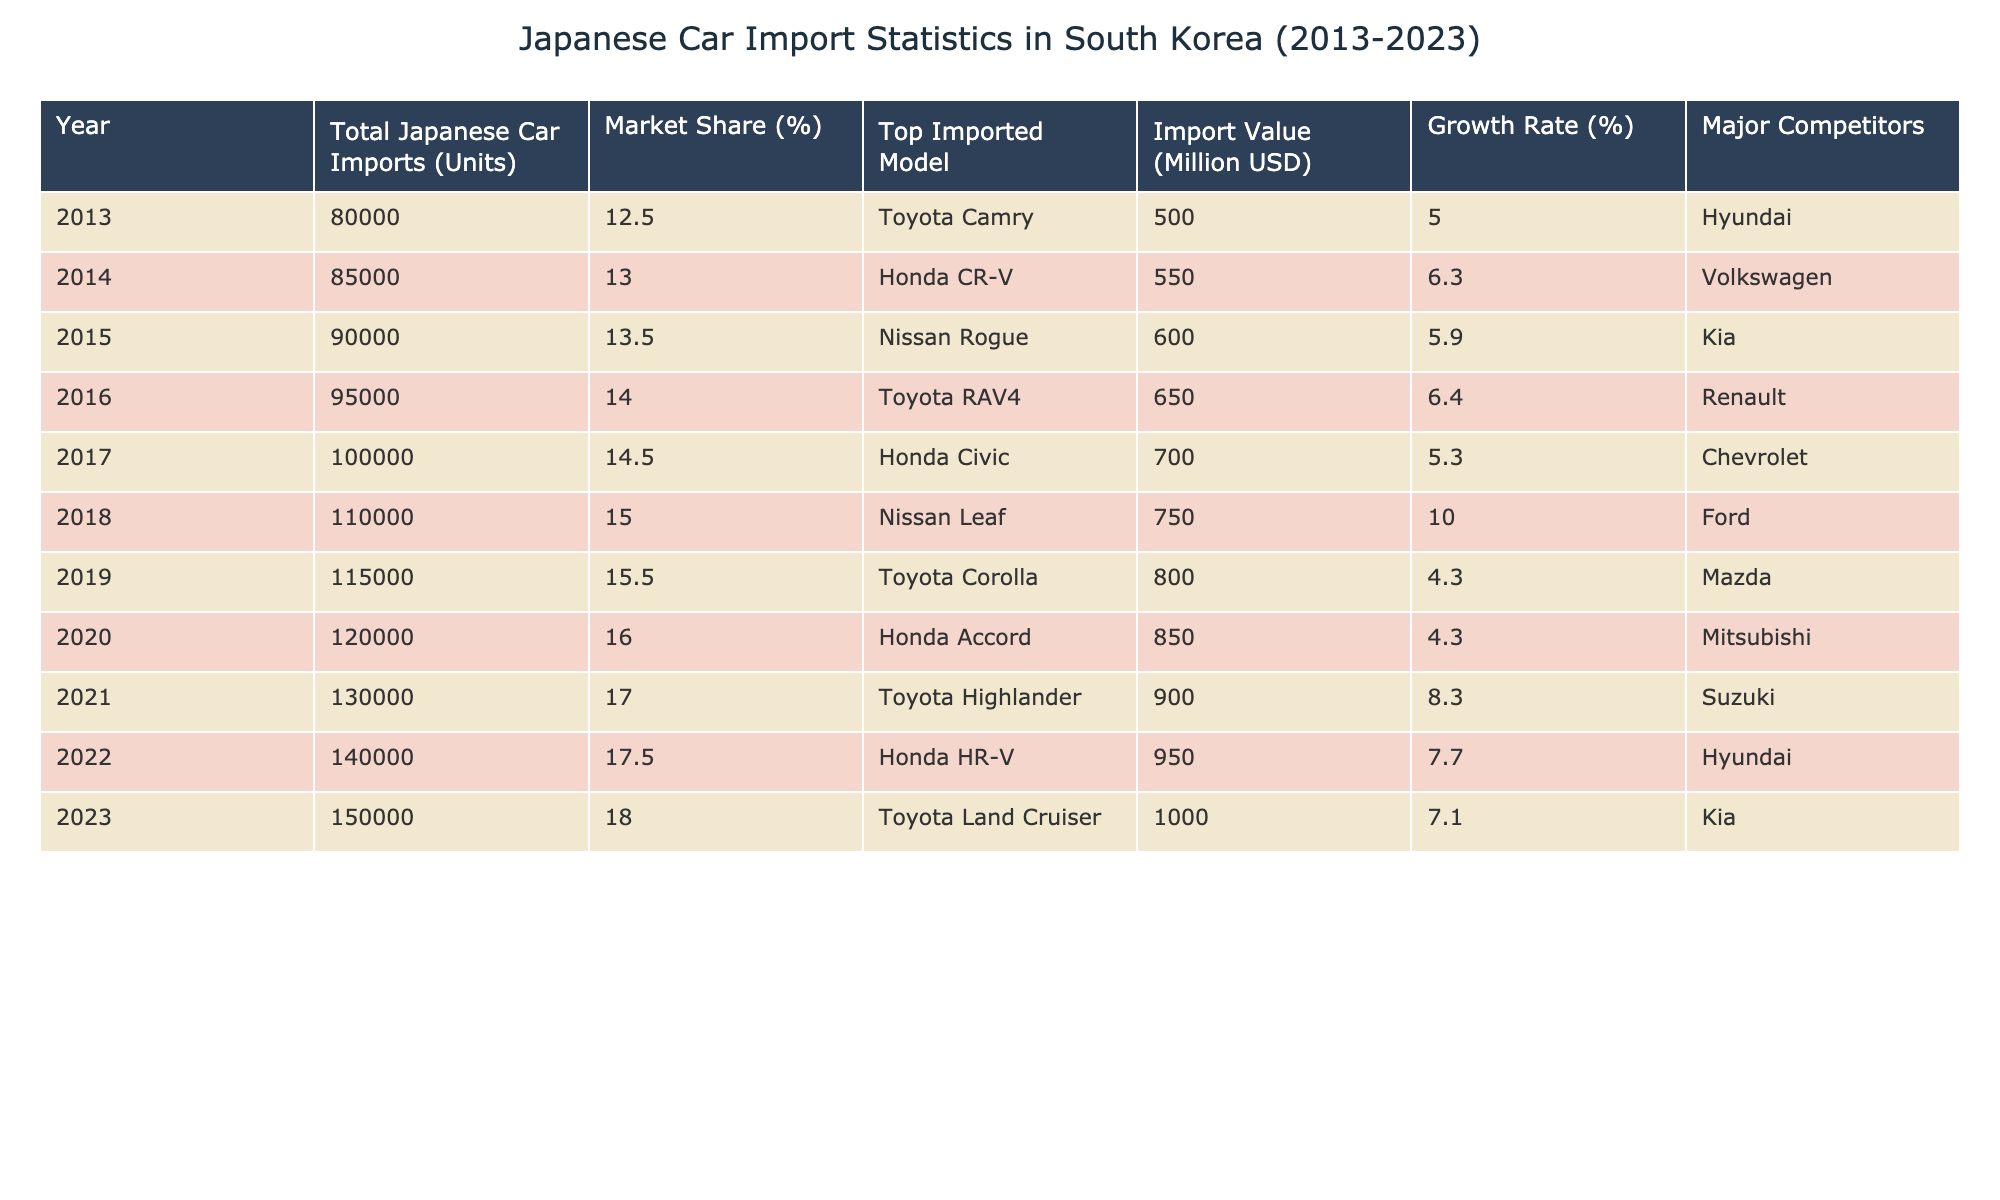What was the total import value of Japanese cars in South Korea in 2018? The table shows that the import value of Japanese cars in 2018 was recorded at 750 million USD. This value can be found in the "Import Value" column for the year 2018.
Answer: 750 million USD Which year had the highest market share for Japanese car imports? Looking at the "Market Share" column, the highest percentage is 18.0%, which occurred in 2023. Therefore, 2023 is the year with the highest market share for Japanese car imports in South Korea.
Answer: 2023 What is the growth rate from 2022 to 2023? The growth rate for 2022 is 7.7% and for 2023 it's 7.1%. To find the growth rate from 2022 to 2023, we take 7.1 minus 7.7, which equals -0.6. Hence, there was a decline of 0.6%.
Answer: -0.6% Did the Toyota Camry maintain its position as the top imported model across the decade? The top imported model in 2013 was the Toyota Camry, but other models topped the list in subsequent years. By looking through all the years, it is evident that the Toyota Camry was only the top model in 2013, so the answer is no.
Answer: No What was the average number of Japanese car imports over the last decade? To determine the average, sum up all the total imports from 2013 to 2023, which is 80000 + 85000 + 90000 + 95000 + 100000 + 110000 + 115000 + 120000 + 130000 + 140000 + 150000 = 1,350,000 units. Dividing this by the number of years (11), we derive an average of approximately 122727.27.
Answer: 122727.27 In which year did Nissan reach its peak import value, and what was that value? The highest import value attributed to a Nissan model was in 2015 with the Nissan Rogue, which had an import value of 600 million USD. Other models did not exceed this in value at any year during the decade.
Answer: 600 million USD Was there a year when the total Japanese car imports exceeded 100,000 units? By examining the table, total Japanese car imports exceeded 100,000 units starting in 2017, continuing to grow until 2023. Hence, the answer is yes, as 2017 and the following years all show values above 100,000 units.
Answer: Yes What major competitor was listed from 2013 to 2016, and did that remain consistent over time? The major competitor from 2013 to 2016 was Hyundai, Volkswagen, and Kia, with each corresponding to specific years. However, this competitor changed in 2017 to Chevrolet and continued with various competitors each subsequent year. Therefore, it was not consistent over the years.
Answer: No 